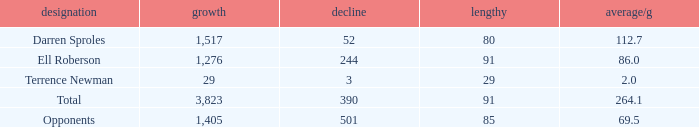When the player gained below 1,405 yards and lost over 390 yards, what's the sum of the long yards? None. 